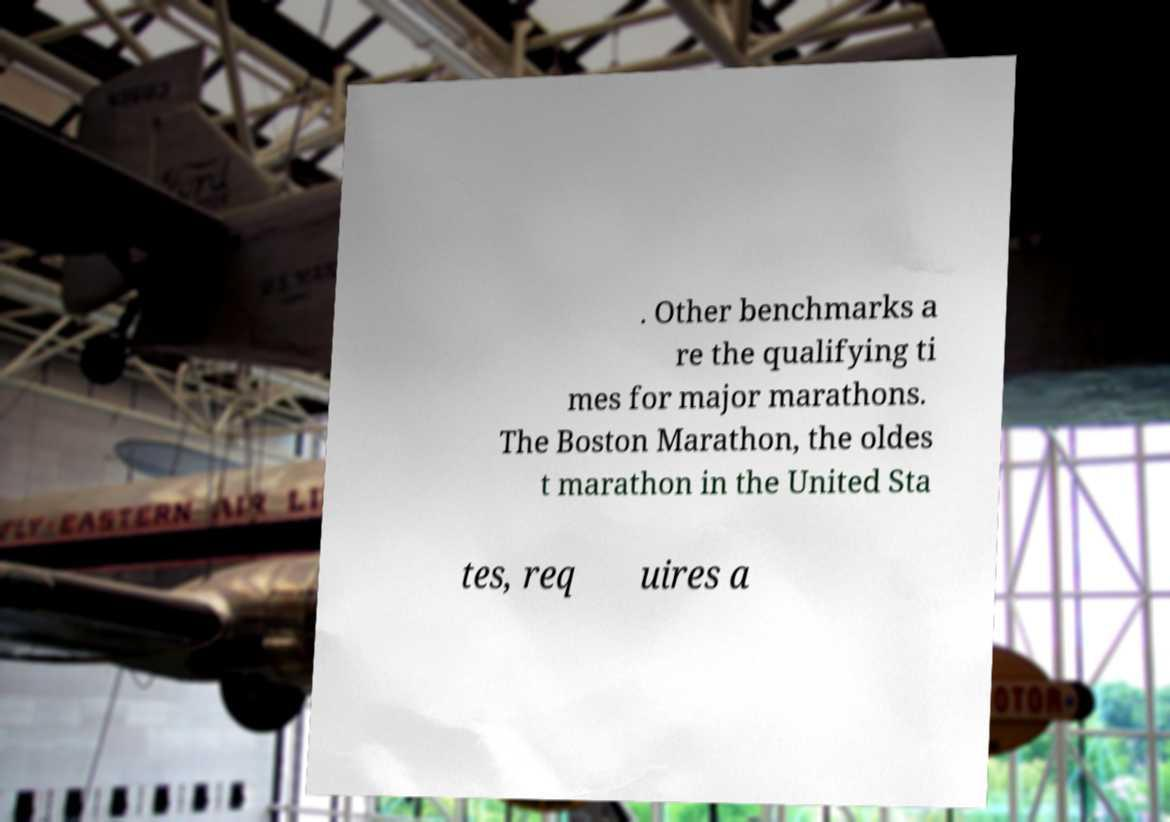There's text embedded in this image that I need extracted. Can you transcribe it verbatim? . Other benchmarks a re the qualifying ti mes for major marathons. The Boston Marathon, the oldes t marathon in the United Sta tes, req uires a 